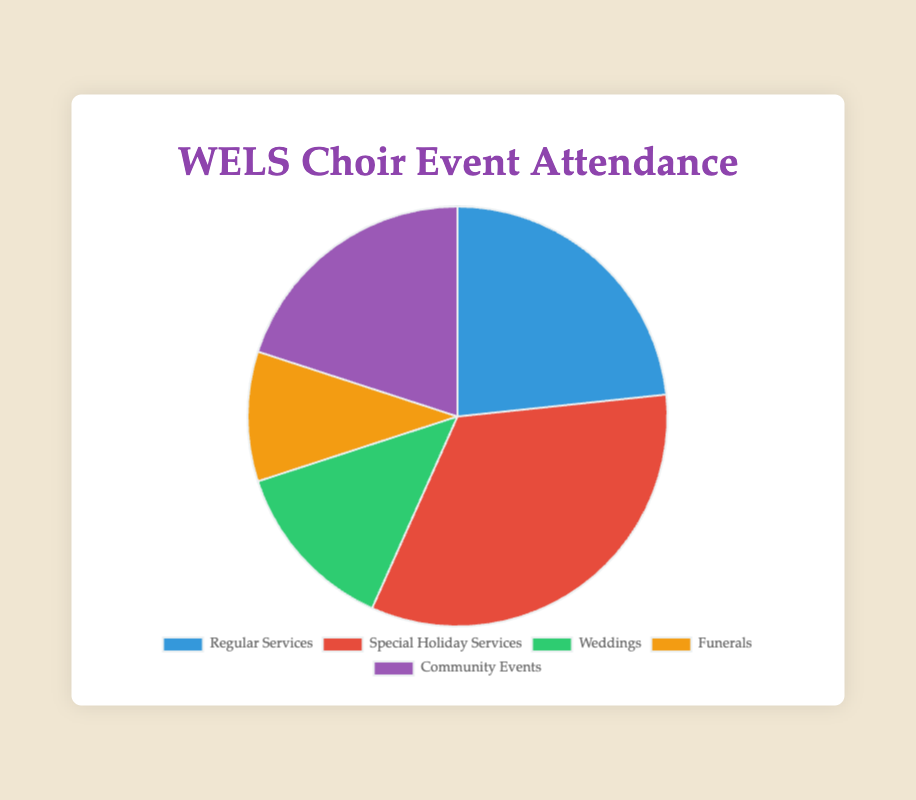What is the event with the highest attendance? Looking at the pie chart, 'Special Holiday Services' has the largest segment, signifying the highest attendance.
Answer: Special Holiday Services Which event has the lowest attendance? The smallest segment in the pie chart corresponds to 'Funerals', indicating it has the lowest attendance.
Answer: Funerals What is the total attendance across all events? Sum the attendance of all events: 350 (Regular Services) + 500 (Special Holiday Services) + 200 (Weddings) + 150 (Funerals) + 300 (Community Events) = 1500
Answer: 1500 What's the difference in attendance between Regular Services and Special Holiday Services? Subtract the attendance of Regular Services (350) from Special Holiday Services (500): 500 - 350 = 150
Answer: 150 Which event has an attendance closer to that of Weddings: Regular Services or Community Events? Weddings attendance is 200. Regular Services have 350 attendees and Community Events have 300. The difference is 350 - 200 = 150 for Regular Services, and 300 - 200 = 100 for Community Events. Since 100 < 150, Community Events are closer.
Answer: Community Events How much more is the attendance of Special Holiday Services compared to Funerals? Subtract the attendance of Funerals (150) from Special Holiday Services (500): 500 - 150 = 350
Answer: 350 What percentage of the total attendance does the Weddings event represent? Calculate the percentage by dividing Weddings attendance by total attendance and then multiplying by 100: (200 / 1500) * 100 = ~13.33%
Answer: ~13.33% If the attendance at Community Events increased by 20%, what would the new attendance figure be? Calculate 20% of Community Events attendance (300): 0.20 * 300 = 60. Add this to the original figure: 300 + 60 = 360
Answer: 360 Which event's attendance is closer to the average attendance of all events? First, find the average attendance: total attendance (1500) / number of events (5) = 300. Regular Services and Community Events both have attendances of 300, matching the average exactly.
Answer: Regular Services and Community Events 